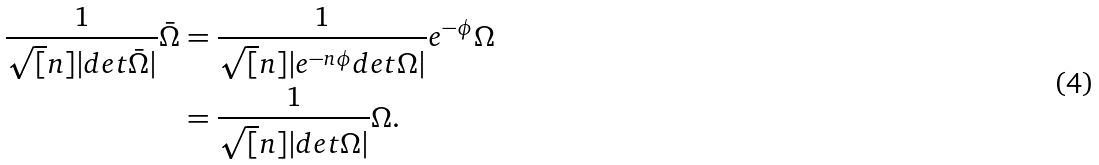Convert formula to latex. <formula><loc_0><loc_0><loc_500><loc_500>\frac { 1 } { \sqrt { [ } n ] { | d e t \bar { \Omega } | } } \bar { \Omega } & = \frac { 1 } { \sqrt { [ } n ] { | e ^ { - n \phi } d e t \Omega | } } e ^ { - \phi } \Omega \\ & = \frac { 1 } { \sqrt { [ } n ] { | d e t \Omega | } } \Omega .</formula> 